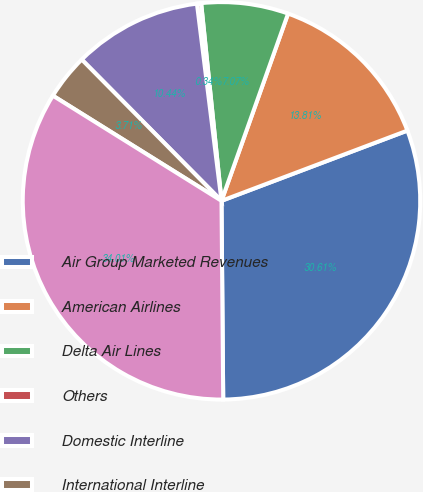Convert chart to OTSL. <chart><loc_0><loc_0><loc_500><loc_500><pie_chart><fcel>Air Group Marketed Revenues<fcel>American Airlines<fcel>Delta Air Lines<fcel>Others<fcel>Domestic Interline<fcel>International Interline<fcel>Total Operating Revenue<nl><fcel>30.61%<fcel>13.81%<fcel>7.07%<fcel>0.34%<fcel>10.44%<fcel>3.71%<fcel>34.01%<nl></chart> 